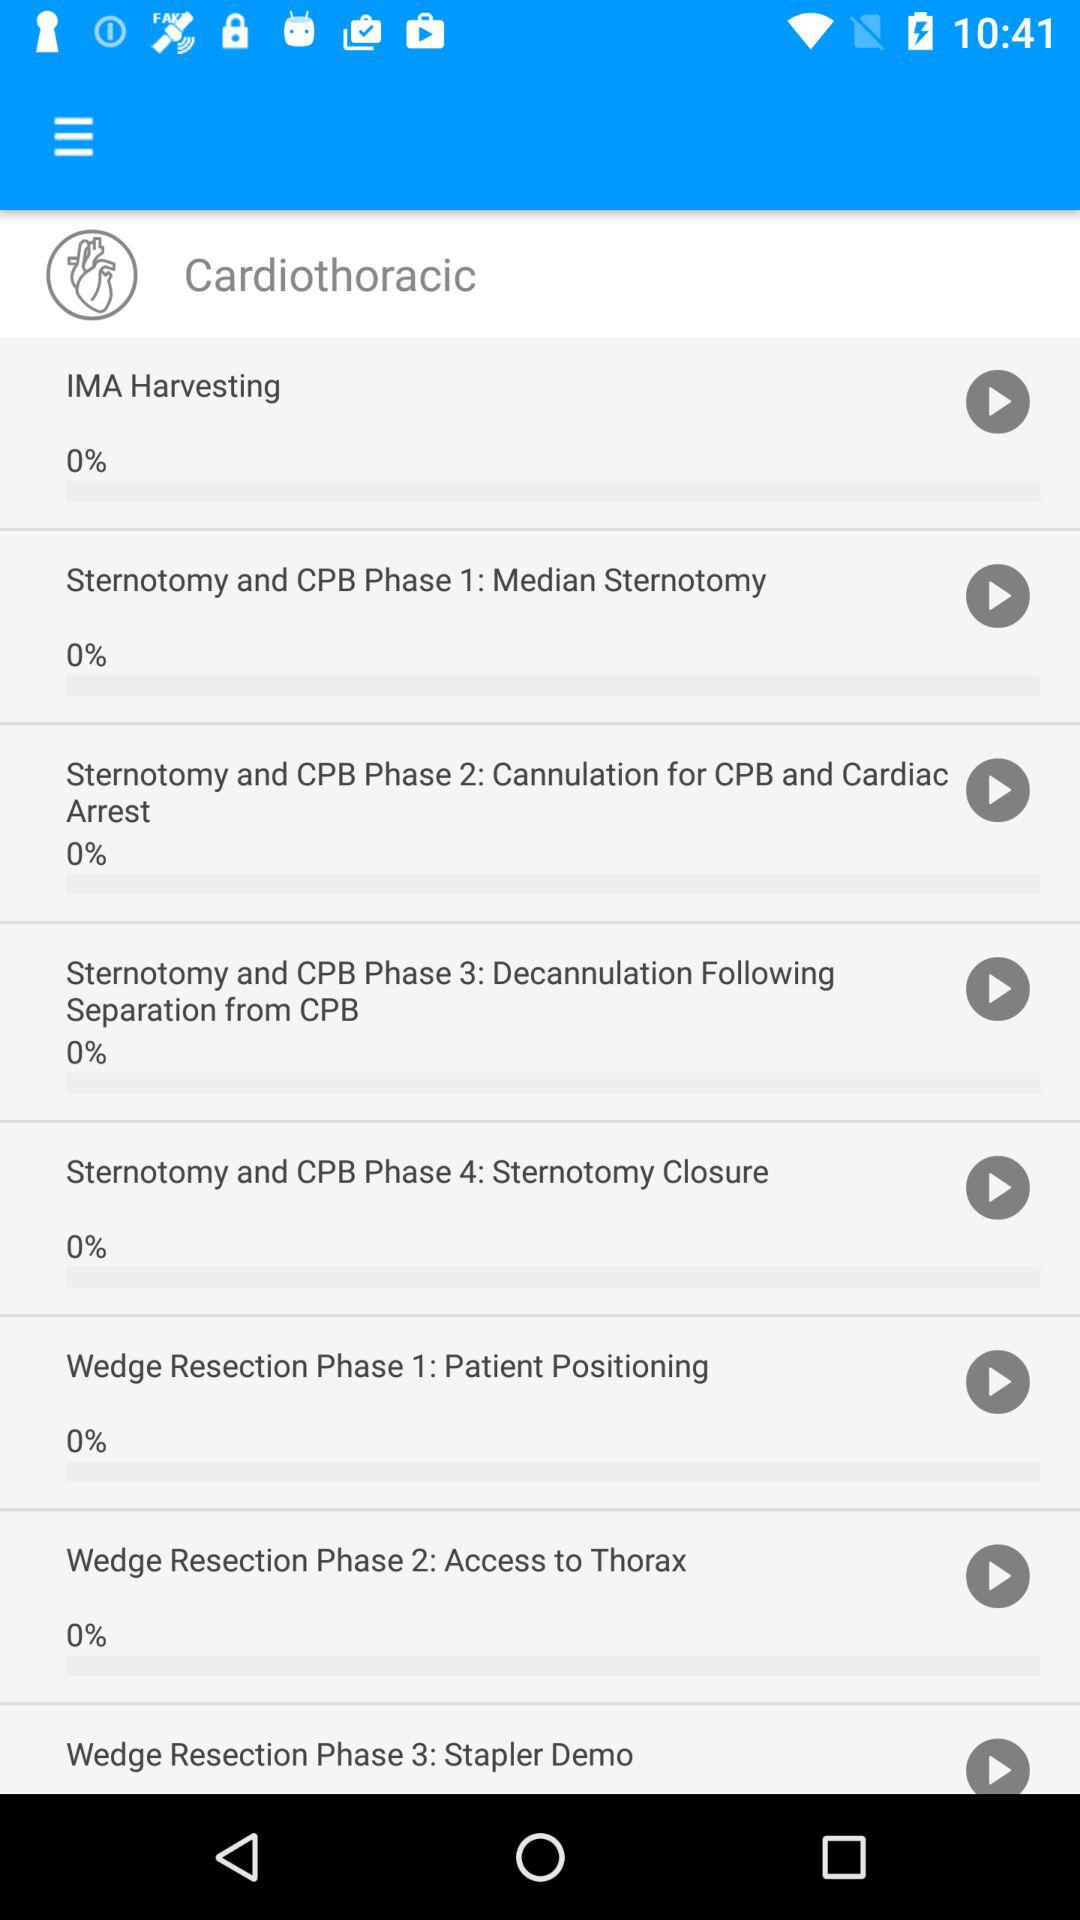What's the percentage of "Wedge Resection Phase 1"? The percentage of "Wedge Resection Phase 1" is 0. 